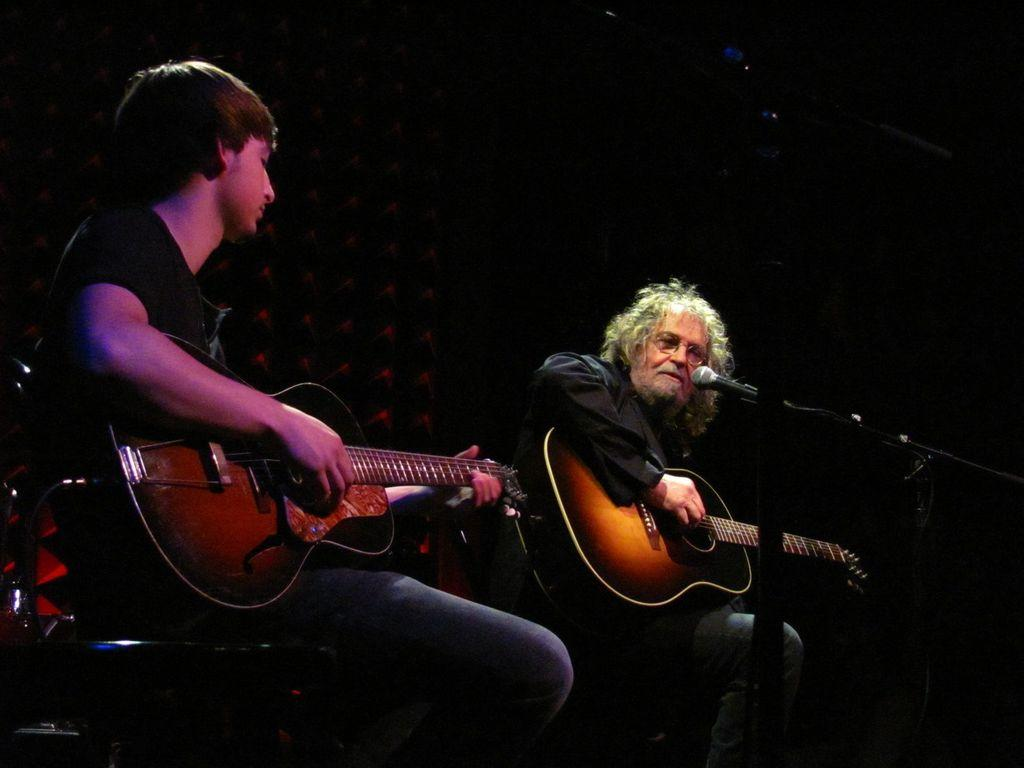How many people are in the image? There are two men in the image. What are the men doing in the image? The men are sitting in a chair and each is holding a guitar. Is there any equipment related to music in the image? Yes, one of the men has a microphone in front of him. How would you describe the lighting in the background of the image? The background has dark lighting. What type of mist can be seen in the image? There is no mist present in the image. What does the image smell like? It is not possible to determine the smell of the image through a visual representation. 